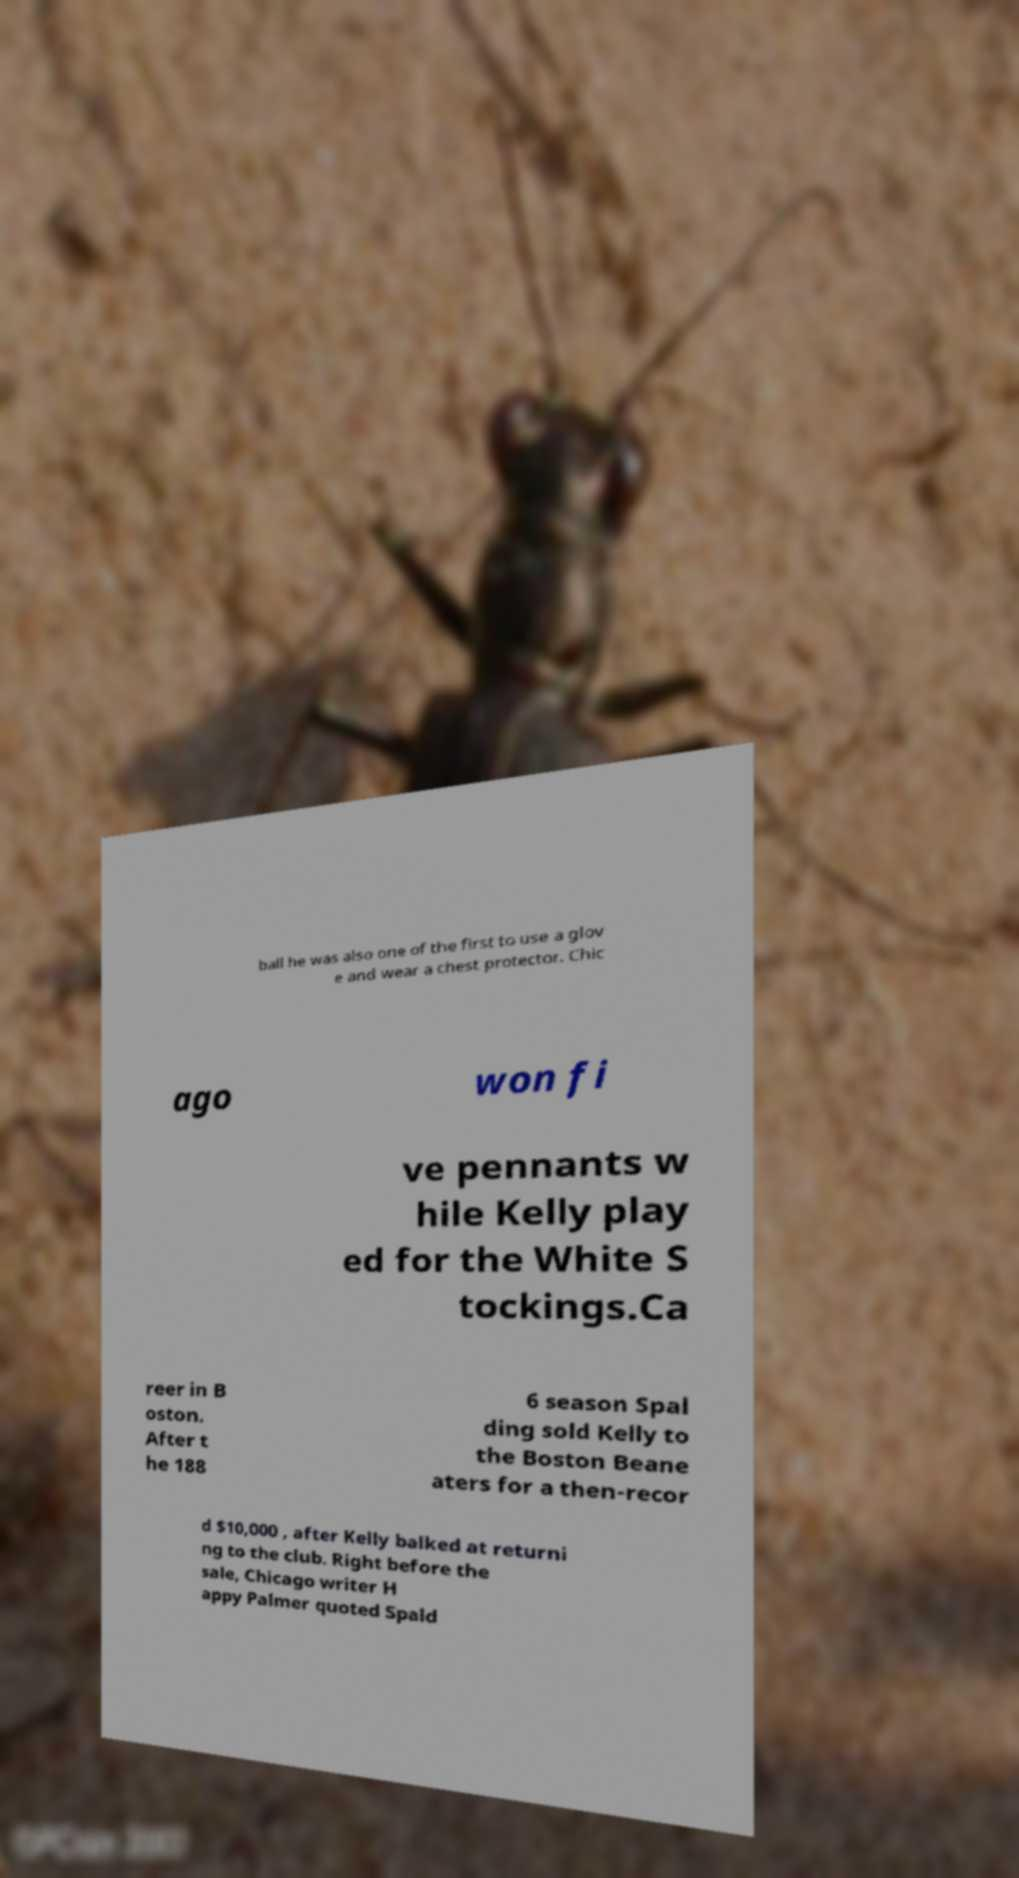What messages or text are displayed in this image? I need them in a readable, typed format. ball he was also one of the first to use a glov e and wear a chest protector. Chic ago won fi ve pennants w hile Kelly play ed for the White S tockings.Ca reer in B oston. After t he 188 6 season Spal ding sold Kelly to the Boston Beane aters for a then-recor d $10,000 , after Kelly balked at returni ng to the club. Right before the sale, Chicago writer H appy Palmer quoted Spald 